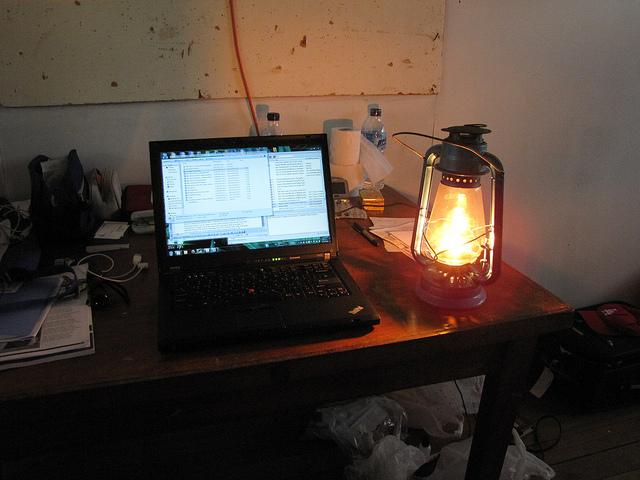What type of light source is next to the laptop? Please explain your reasoning. lantern. This is a lantern that is on the desk. 